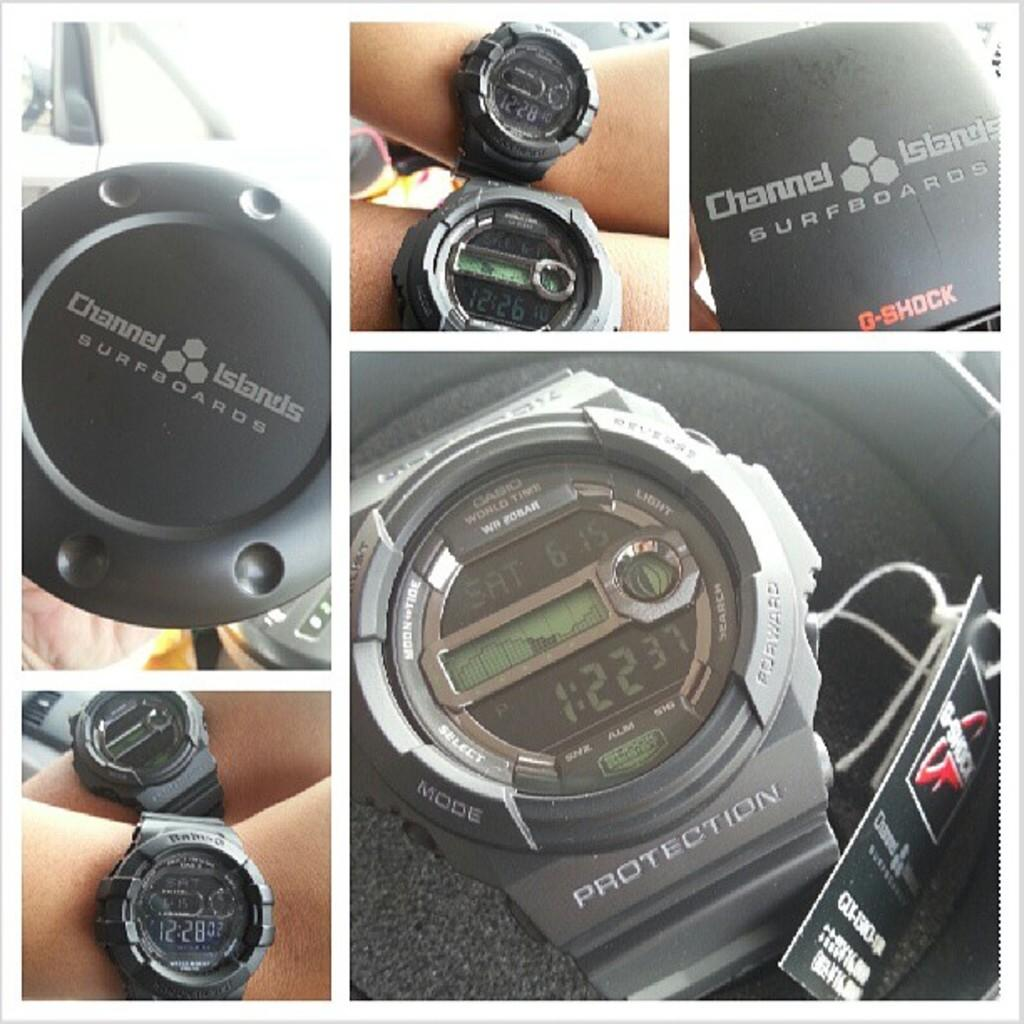Provide a one-sentence caption for the provided image. many different shot of Channel Islands Surfboard G-shock wrist watch. 